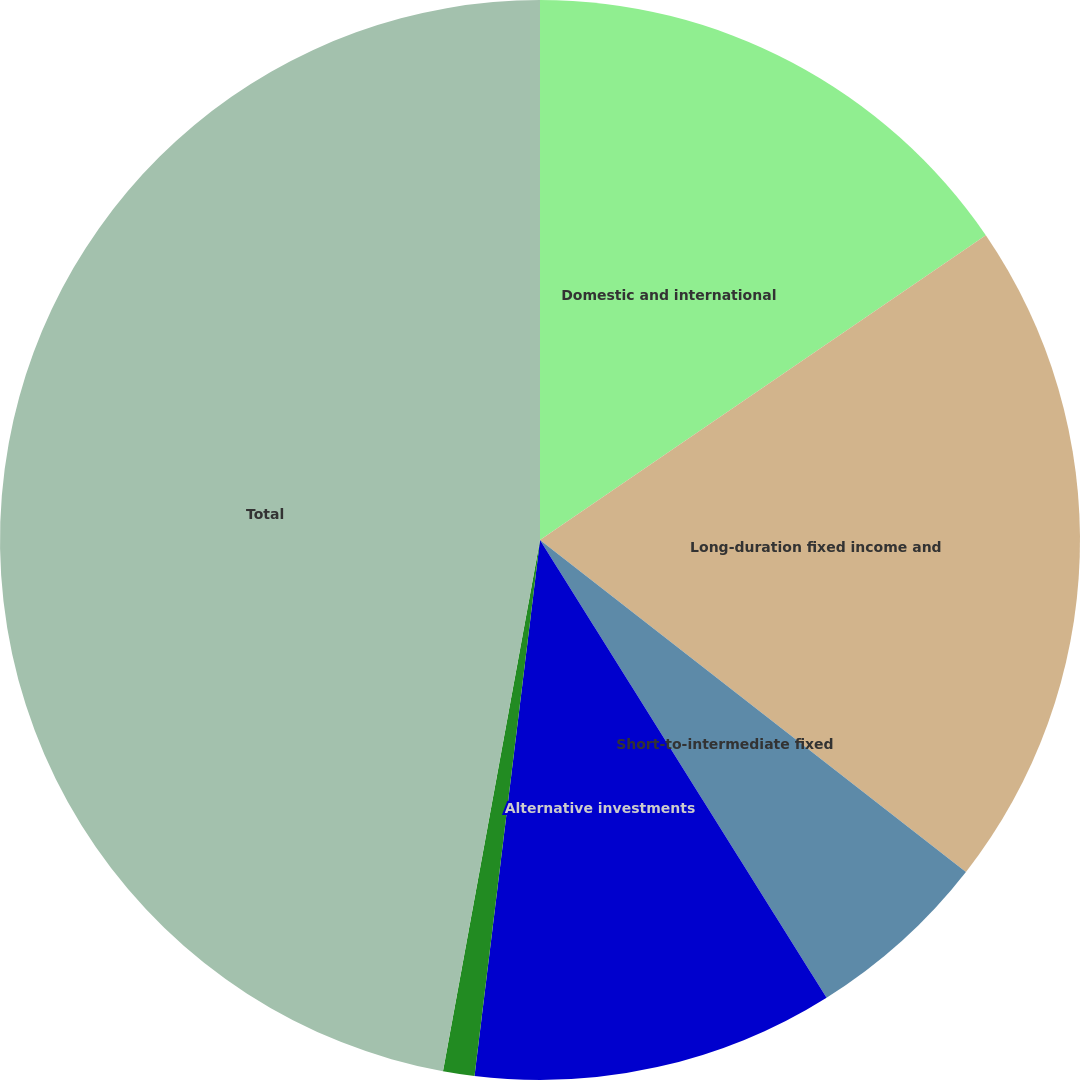Convert chart to OTSL. <chart><loc_0><loc_0><loc_500><loc_500><pie_chart><fcel>Domestic and international<fcel>Long-duration fixed income and<fcel>Short-to-intermediate fixed<fcel>Alternative investments<fcel>Cash<fcel>Total<nl><fcel>15.46%<fcel>20.08%<fcel>5.56%<fcel>10.84%<fcel>0.94%<fcel>47.13%<nl></chart> 